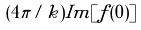<formula> <loc_0><loc_0><loc_500><loc_500>( 4 \pi / k ) I m [ f ( 0 ) ]</formula> 